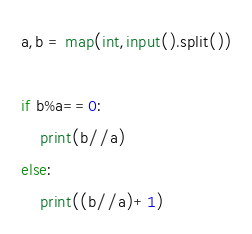Convert code to text. <code><loc_0><loc_0><loc_500><loc_500><_Python_>a,b = map(int,input().split())

if b%a==0:
    print(b//a)
else:
    print((b//a)+1)</code> 